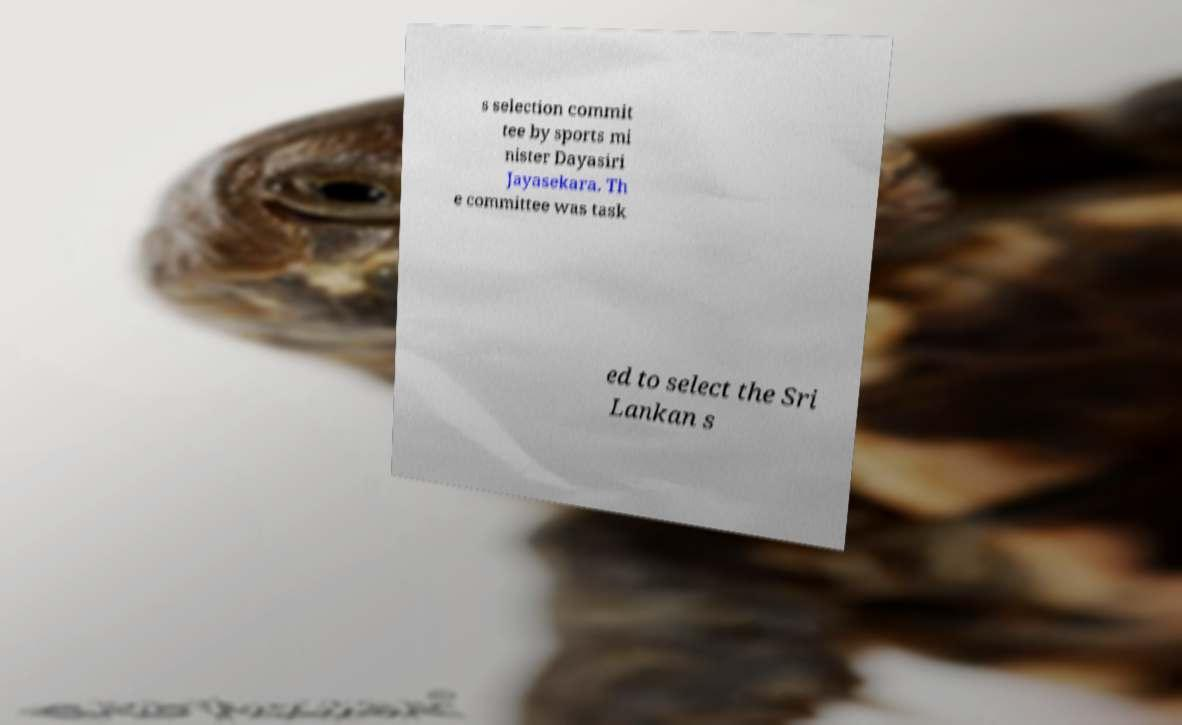What messages or text are displayed in this image? I need them in a readable, typed format. s selection commit tee by sports mi nister Dayasiri Jayasekara. Th e committee was task ed to select the Sri Lankan s 